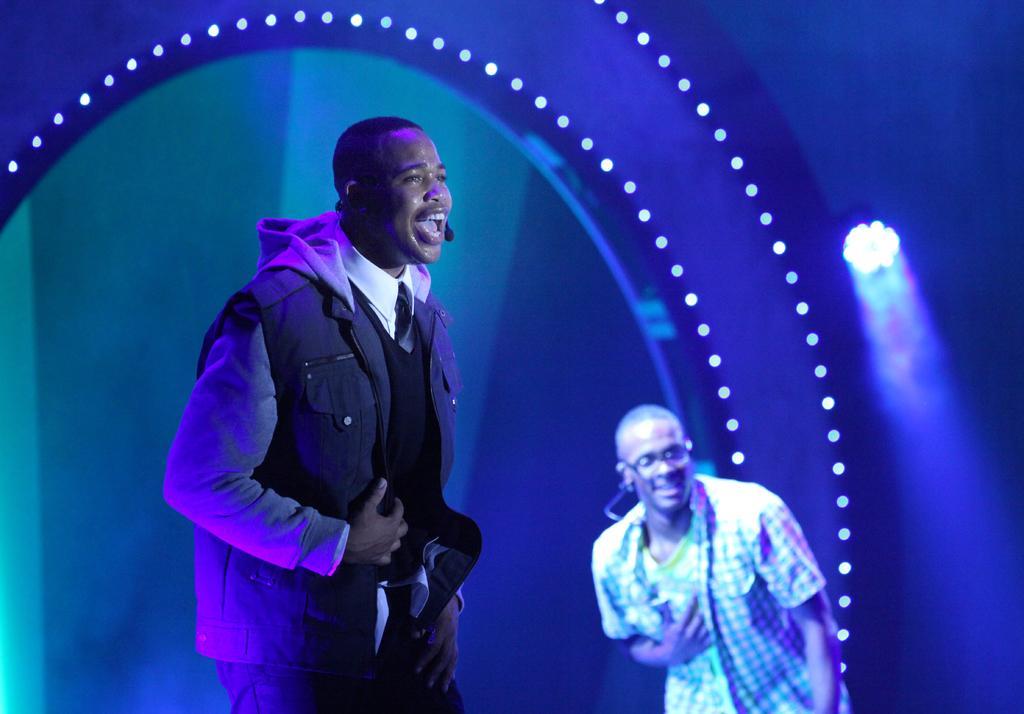Please provide a concise description of this image. In this image we can see a man standing, next to him there is another man. In the background there are lights. 